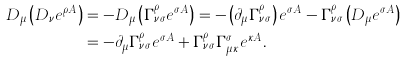Convert formula to latex. <formula><loc_0><loc_0><loc_500><loc_500>D _ { \mu } \left ( D _ { \nu } e ^ { \rho A } \right ) & = - D _ { \mu } \left ( \Gamma _ { \nu \sigma } ^ { \rho } e ^ { \sigma A } \right ) = - \left ( \partial _ { \mu } \Gamma _ { \nu \sigma } ^ { \rho } \right ) e ^ { \sigma A } - \Gamma _ { \nu \sigma } ^ { \rho } \left ( D _ { \mu } e ^ { \sigma A } \right ) \\ & = - \partial _ { \mu } \Gamma _ { \nu \sigma } ^ { \rho } e ^ { \sigma A } + \Gamma _ { \nu \sigma } ^ { \rho } \Gamma _ { \mu \kappa } ^ { \sigma } e ^ { \kappa A } .</formula> 